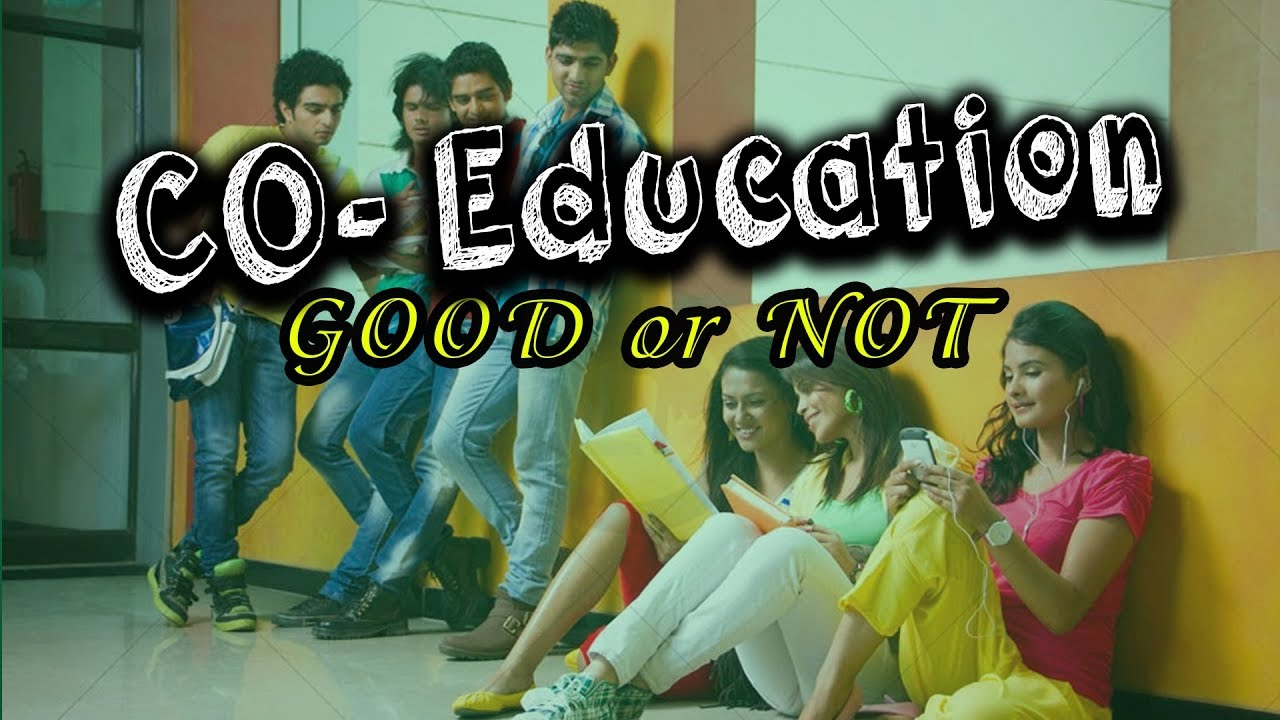Considering the posture and facial expressions of the people in the image, what can be inferred about their level of engagement or interest in the activity they are involved in? The individuals in the image display varying degrees of engagement. The young men leaning against the glass wall seem to be actively involved in a discussion or study session, as indicated by the use of a book or notebook by the first man and the attentive body language of the others. Meanwhile, the young woman with headphones appears to be more absorbed in her mobile phone than in any collaborative activity, suggesting a more relaxed or leisurely demeanor. The other woman, who is reading from her notebook, seems to be focused on her study materials, indicating a personal engagement with her work. Overall, the scene suggests a mix of both social interaction and individual focus among the group. 